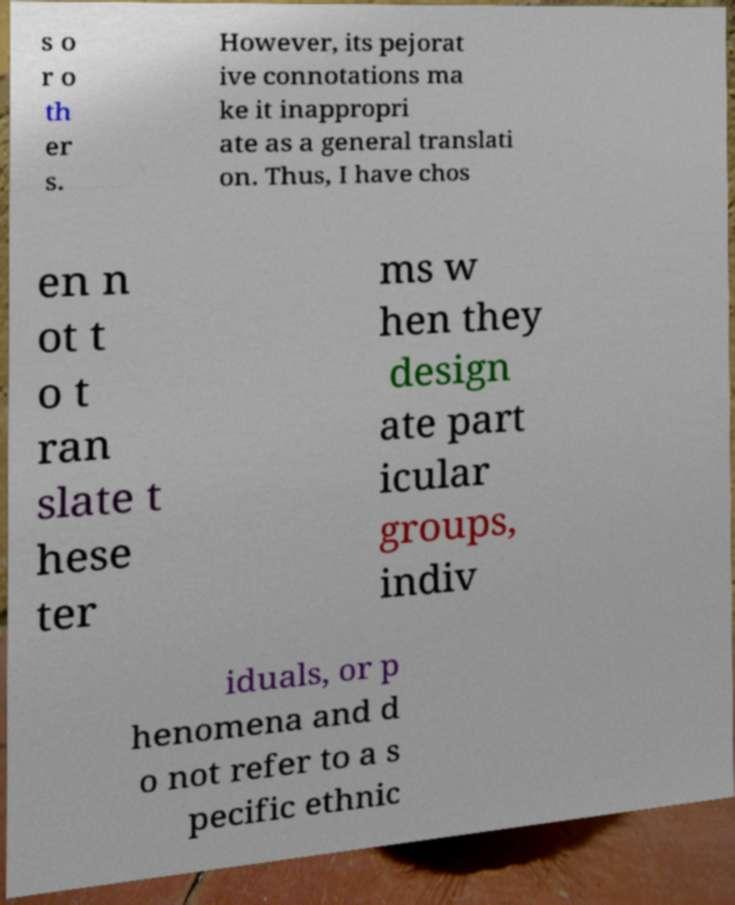Please identify and transcribe the text found in this image. s o r o th er s. However, its pejorat ive connotations ma ke it inappropri ate as a general translati on. Thus, I have chos en n ot t o t ran slate t hese ter ms w hen they design ate part icular groups, indiv iduals, or p henomena and d o not refer to a s pecific ethnic 